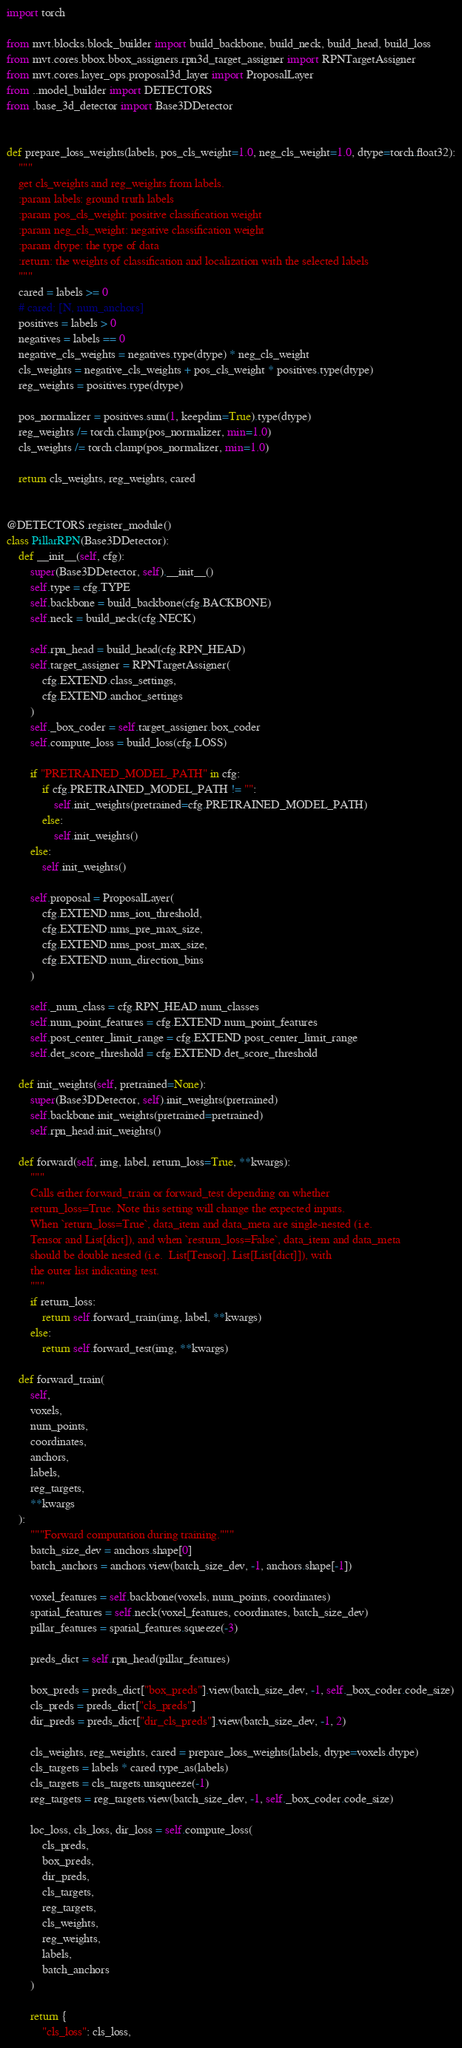Convert code to text. <code><loc_0><loc_0><loc_500><loc_500><_Python_>import torch

from mvt.blocks.block_builder import build_backbone, build_neck, build_head, build_loss
from mvt.cores.bbox.bbox_assigners.rpn3d_target_assigner import RPNTargetAssigner
from mvt.cores.layer_ops.proposal3d_layer import ProposalLayer
from ..model_builder import DETECTORS
from .base_3d_detector import Base3DDetector


def prepare_loss_weights(labels, pos_cls_weight=1.0, neg_cls_weight=1.0, dtype=torch.float32):
    """
    get cls_weights and reg_weights from labels.
    :param labels: ground truth labels
    :param pos_cls_weight: positive classification weight
    :param neg_cls_weight: negative classification weight
    :param dtype: the type of data
    :return: the weights of classification and localization with the selected labels
    """
    cared = labels >= 0
    # cared: [N, num_anchors]
    positives = labels > 0
    negatives = labels == 0
    negative_cls_weights = negatives.type(dtype) * neg_cls_weight
    cls_weights = negative_cls_weights + pos_cls_weight * positives.type(dtype)
    reg_weights = positives.type(dtype)

    pos_normalizer = positives.sum(1, keepdim=True).type(dtype)
    reg_weights /= torch.clamp(pos_normalizer, min=1.0)
    cls_weights /= torch.clamp(pos_normalizer, min=1.0)

    return cls_weights, reg_weights, cared


@DETECTORS.register_module()
class PillarRPN(Base3DDetector):
    def __init__(self, cfg):
        super(Base3DDetector, self).__init__()
        self.type = cfg.TYPE
        self.backbone = build_backbone(cfg.BACKBONE)
        self.neck = build_neck(cfg.NECK)

        self.rpn_head = build_head(cfg.RPN_HEAD)
        self.target_assigner = RPNTargetAssigner(
            cfg.EXTEND.class_settings,
            cfg.EXTEND.anchor_settings
        )
        self._box_coder = self.target_assigner.box_coder
        self.compute_loss = build_loss(cfg.LOSS)

        if "PRETRAINED_MODEL_PATH" in cfg:
            if cfg.PRETRAINED_MODEL_PATH != "":
                self.init_weights(pretrained=cfg.PRETRAINED_MODEL_PATH)
            else:
                self.init_weights()
        else:
            self.init_weights()

        self.proposal = ProposalLayer(
            cfg.EXTEND.nms_iou_threshold,
            cfg.EXTEND.nms_pre_max_size,
            cfg.EXTEND.nms_post_max_size,
            cfg.EXTEND.num_direction_bins
        )
        
        self._num_class = cfg.RPN_HEAD.num_classes
        self.num_point_features = cfg.EXTEND.num_point_features
        self.post_center_limit_range = cfg.EXTEND.post_center_limit_range
        self.det_score_threshold = cfg.EXTEND.det_score_threshold

    def init_weights(self, pretrained=None):
        super(Base3DDetector, self).init_weights(pretrained)
        self.backbone.init_weights(pretrained=pretrained)
        self.rpn_head.init_weights()

    def forward(self, img, label, return_loss=True, **kwargs):
        """
        Calls either forward_train or forward_test depending on whether
        return_loss=True. Note this setting will change the expected inputs.
        When `return_loss=True`, data_item and data_meta are single-nested (i.e.
        Tensor and List[dict]), and when `resturn_loss=False`, data_item and data_meta
        should be double nested (i.e.  List[Tensor], List[List[dict]]), with
        the outer list indicating test.
        """
        if return_loss:
            return self.forward_train(img, label, **kwargs)
        else:
            return self.forward_test(img, **kwargs)

    def forward_train(
        self, 
        voxels, 
        num_points, 
        coordinates, 
        anchors,
        labels,
        reg_targets,
        **kwargs
    ):
        """Forward computation during training."""
        batch_size_dev = anchors.shape[0]
        batch_anchors = anchors.view(batch_size_dev, -1, anchors.shape[-1])

        voxel_features = self.backbone(voxels, num_points, coordinates)
        spatial_features = self.neck(voxel_features, coordinates, batch_size_dev)
        pillar_features = spatial_features.squeeze(-3)

        preds_dict = self.rpn_head(pillar_features)

        box_preds = preds_dict["box_preds"].view(batch_size_dev, -1, self._box_coder.code_size)
        cls_preds = preds_dict["cls_preds"]
        dir_preds = preds_dict["dir_cls_preds"].view(batch_size_dev, -1, 2)

        cls_weights, reg_weights, cared = prepare_loss_weights(labels, dtype=voxels.dtype)
        cls_targets = labels * cared.type_as(labels)
        cls_targets = cls_targets.unsqueeze(-1)
        reg_targets = reg_targets.view(batch_size_dev, -1, self._box_coder.code_size)

        loc_loss, cls_loss, dir_loss = self.compute_loss(
            cls_preds,
            box_preds,
            dir_preds,
            cls_targets,
            reg_targets,
            cls_weights,
            reg_weights,
            labels,
            batch_anchors
        )

        return {
            "cls_loss": cls_loss,</code> 